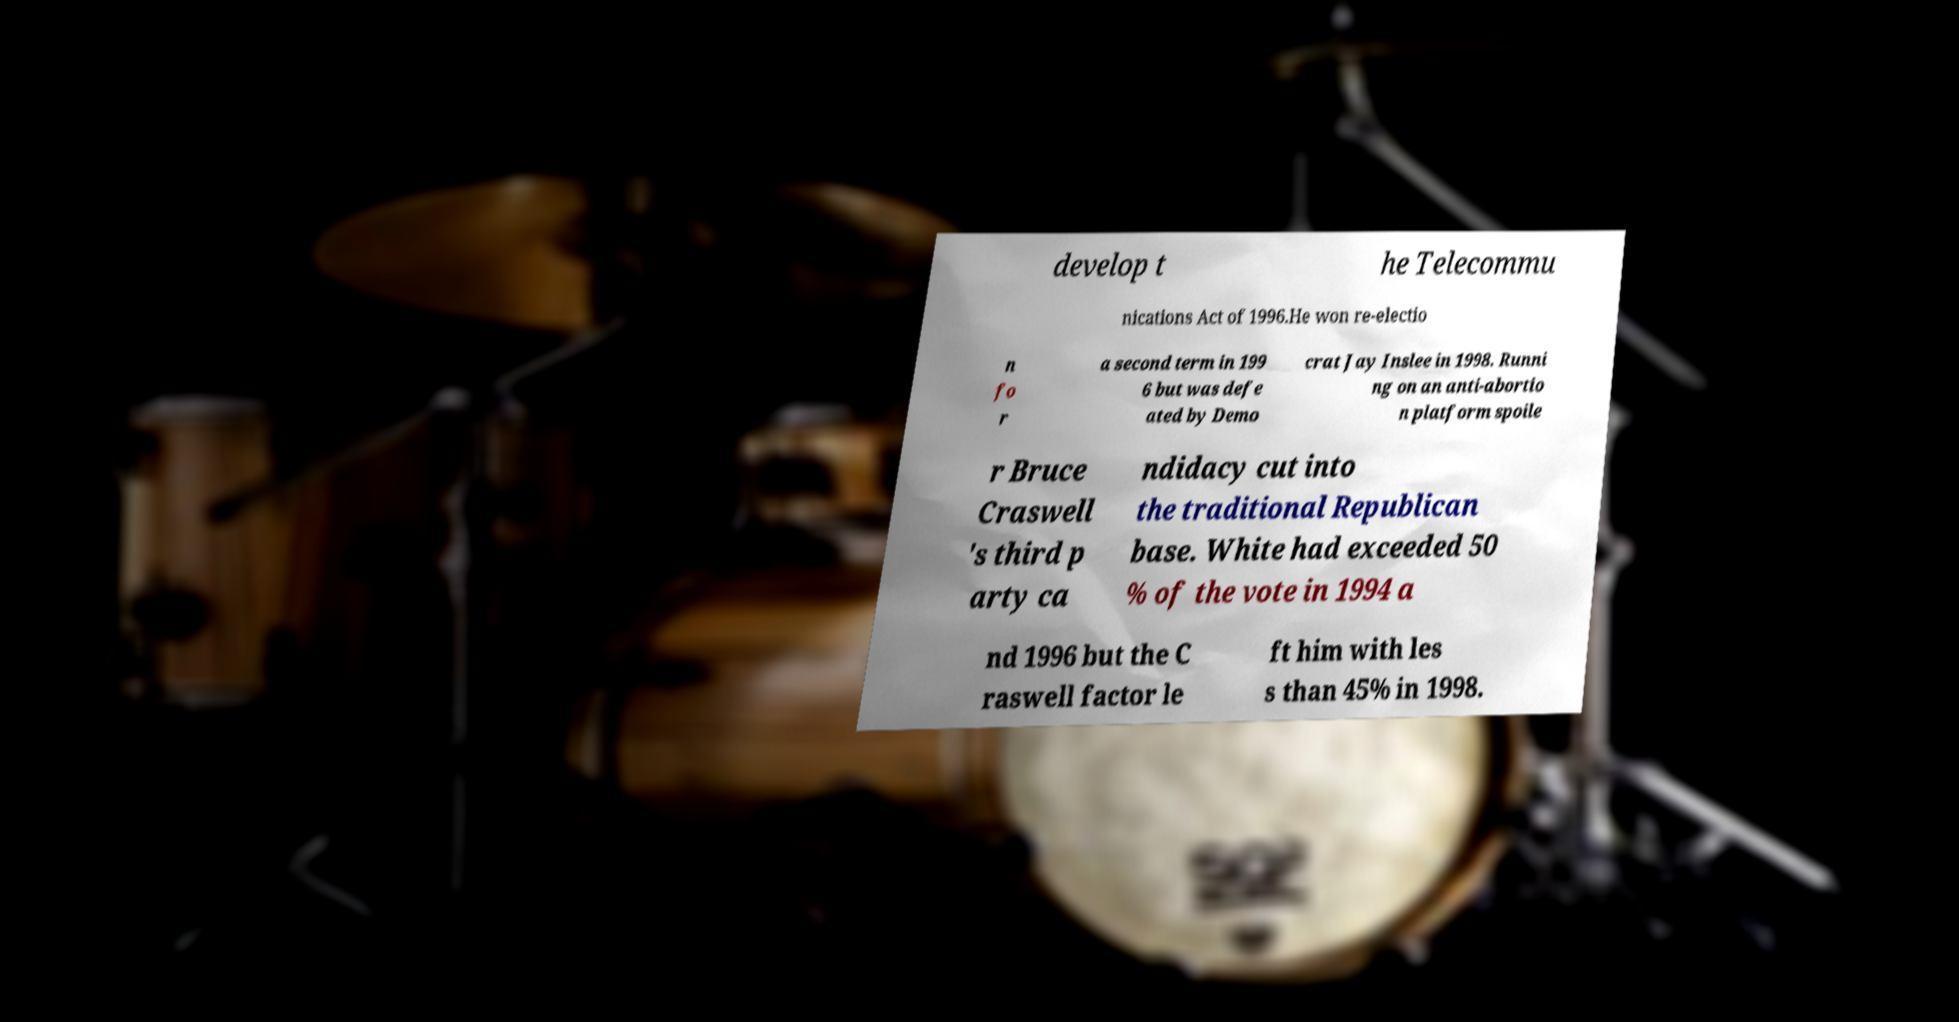What messages or text are displayed in this image? I need them in a readable, typed format. develop t he Telecommu nications Act of 1996.He won re-electio n fo r a second term in 199 6 but was defe ated by Demo crat Jay Inslee in 1998. Runni ng on an anti-abortio n platform spoile r Bruce Craswell 's third p arty ca ndidacy cut into the traditional Republican base. White had exceeded 50 % of the vote in 1994 a nd 1996 but the C raswell factor le ft him with les s than 45% in 1998. 